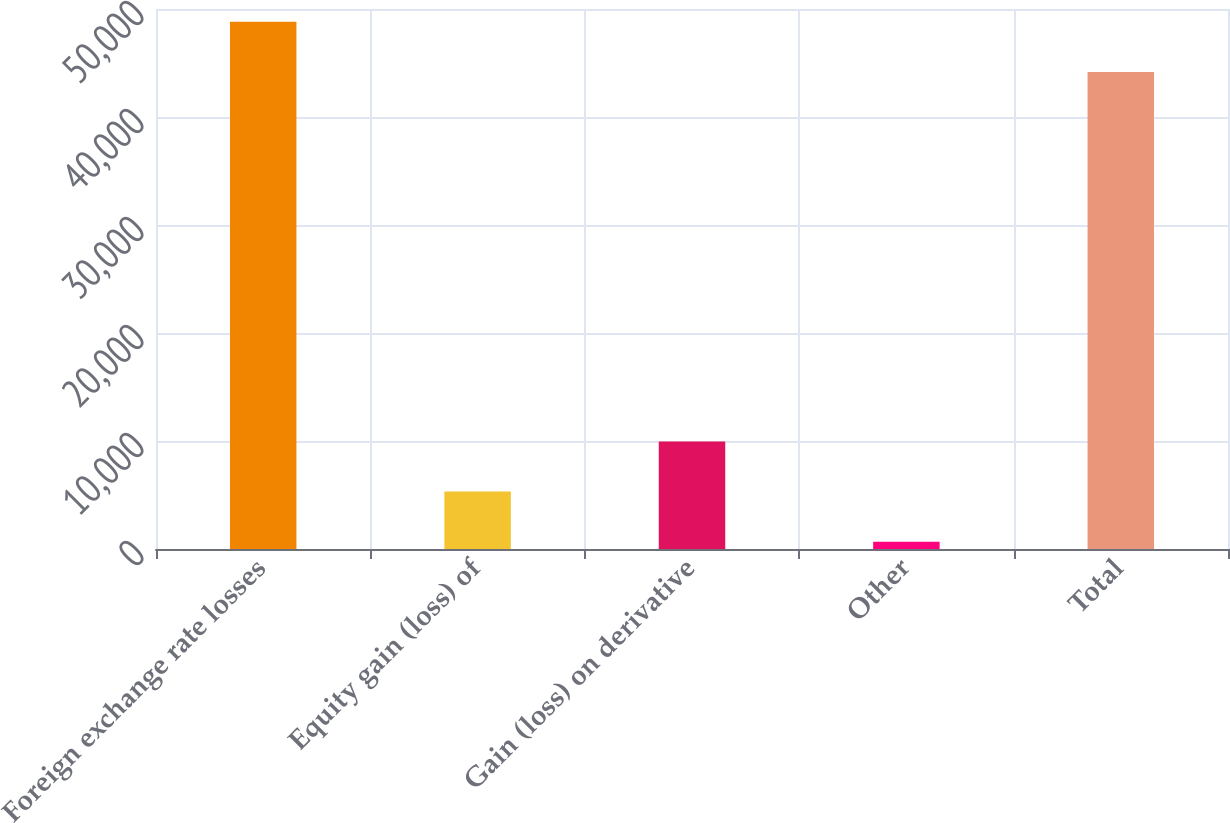Convert chart to OTSL. <chart><loc_0><loc_0><loc_500><loc_500><bar_chart><fcel>Foreign exchange rate losses<fcel>Equity gain (loss) of<fcel>Gain (loss) on derivative<fcel>Other<fcel>Total<nl><fcel>48823.9<fcel>5315.9<fcel>9961.8<fcel>670<fcel>44178<nl></chart> 